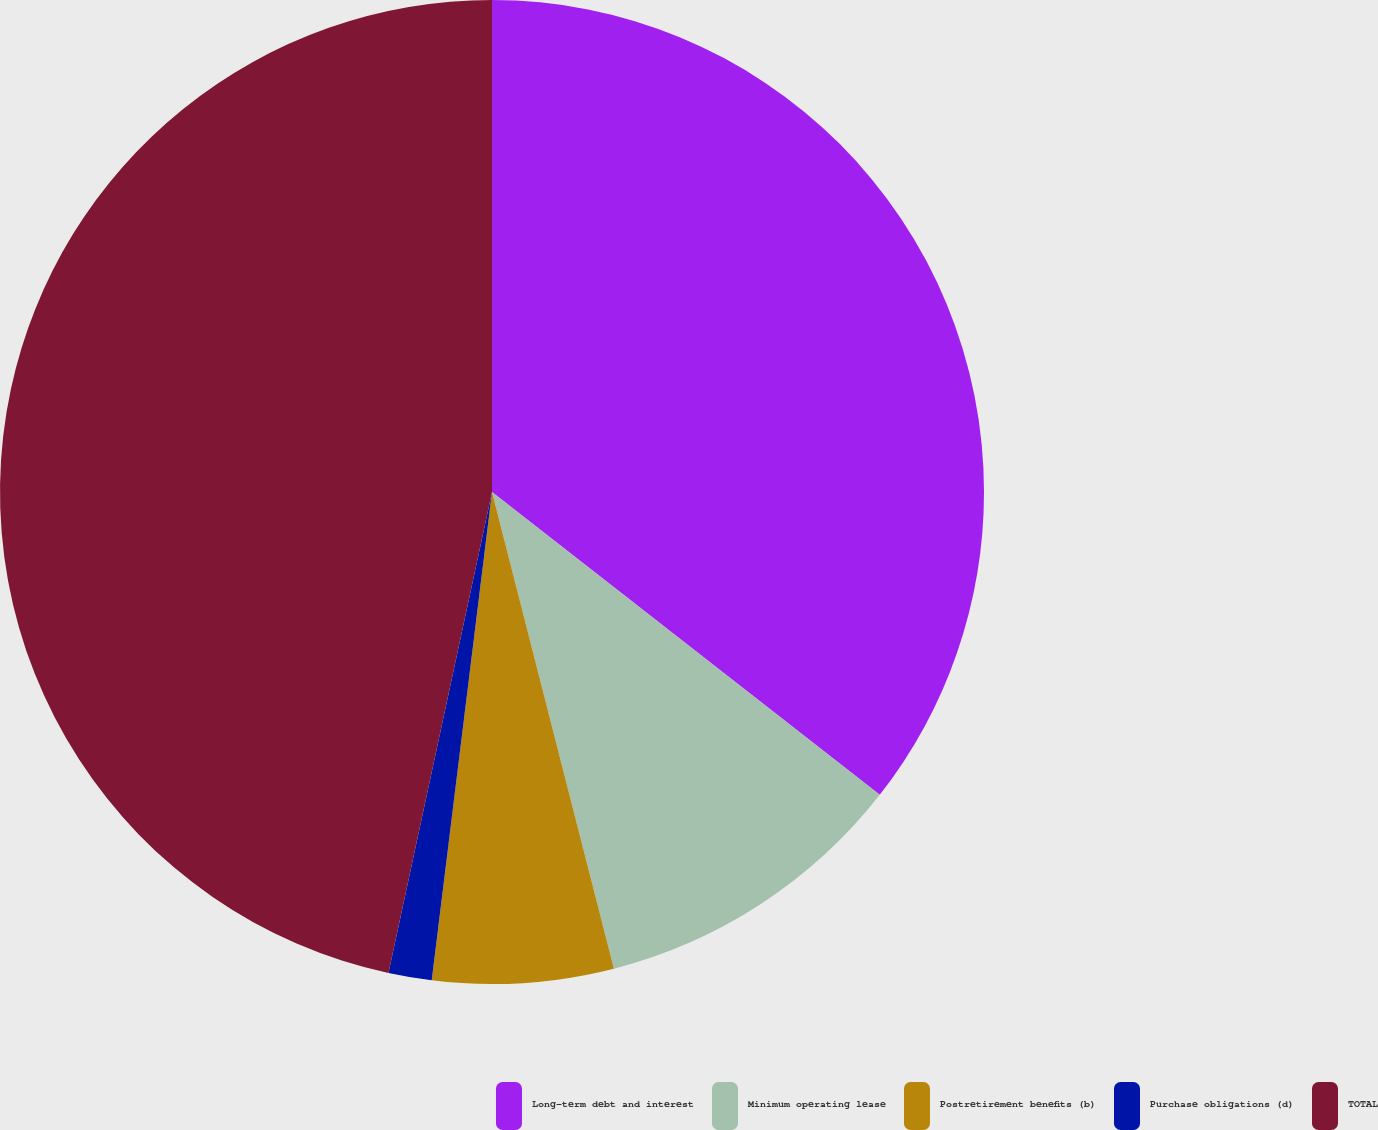Convert chart. <chart><loc_0><loc_0><loc_500><loc_500><pie_chart><fcel>Long-term debt and interest<fcel>Minimum operating lease<fcel>Postretirement benefits (b)<fcel>Purchase obligations (d)<fcel>TOTAL<nl><fcel>35.55%<fcel>10.46%<fcel>5.94%<fcel>1.42%<fcel>46.62%<nl></chart> 